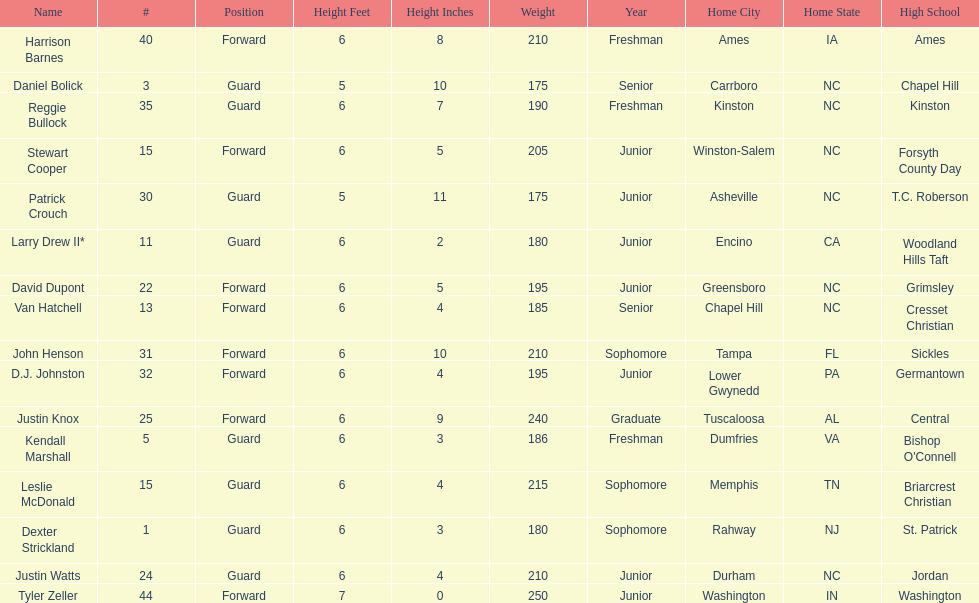Total number of players whose home town was in north carolina (nc) 7. 